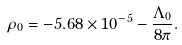Convert formula to latex. <formula><loc_0><loc_0><loc_500><loc_500>\rho _ { 0 } = - 5 . 6 8 \times 1 0 ^ { - 5 } - \frac { \Lambda _ { 0 } } { 8 \pi } .</formula> 